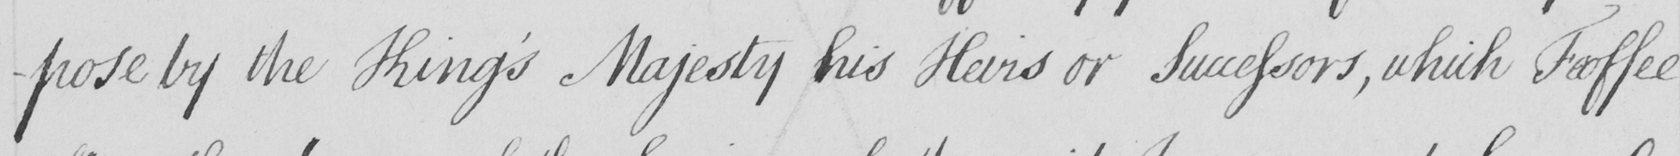What does this handwritten line say? -pose by the King ' s Majesty his Heirs or Successors , which Feoffee 